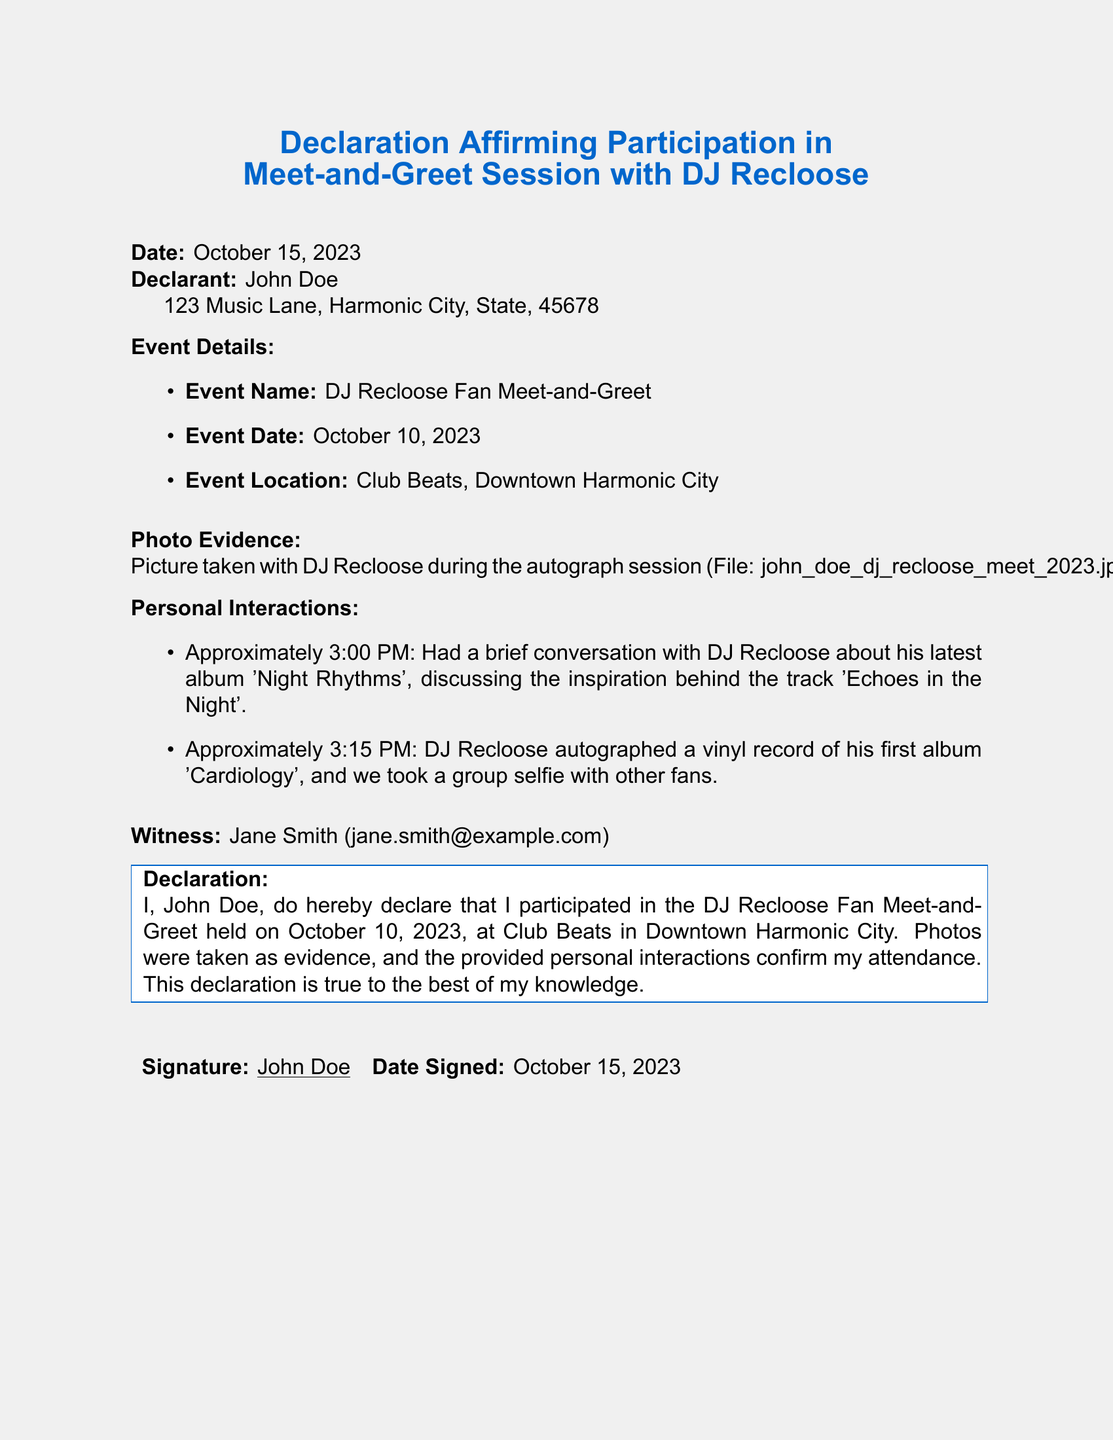What is the date of the event? The date of the event is explicitly mentioned in the document under the event details section as October 10, 2023.
Answer: October 10, 2023 Who is the declarant? The declarant's name is stated at the top of the document, specifically John Doe.
Answer: John Doe Where was the meet-and-greet held? The event location is listed in the event details section as Club Beats, Downtown Harmonic City.
Answer: Club Beats, Downtown Harmonic City What time did the conversation with DJ Recloose take place? The document specifies that the conversation occurred at approximately 3:00 PM.
Answer: 3:00 PM What photo evidence is mentioned? The document includes a reference to a specific file name that serves as photo evidence, which is john_doe_dj_recloose_meet_2023.jpg.
Answer: john_doe_dj_recloose_meet_2023.jpg What item did DJ Recloose autograph? The declarant mentions in the personal interactions section that DJ Recloose autographed a vinyl record of his first album 'Cardiology'.
Answer: vinyl record of 'Cardiology' What is the declaration's purpose? The purpose of the declaration is to affirm participation in the DJ Recloose Fan Meet-and-Greet held on October 10, 2023.
Answer: To affirm participation in the meet-and-greet Who witnessed the declaration? The witness is named in the document as Jane Smith, along with her email address.
Answer: Jane Smith What was discussed during the meeting? The declarant mentioned discussing the inspiration behind the track 'Echoes in the Night'.
Answer: Inspiration behind 'Echoes in the Night' 